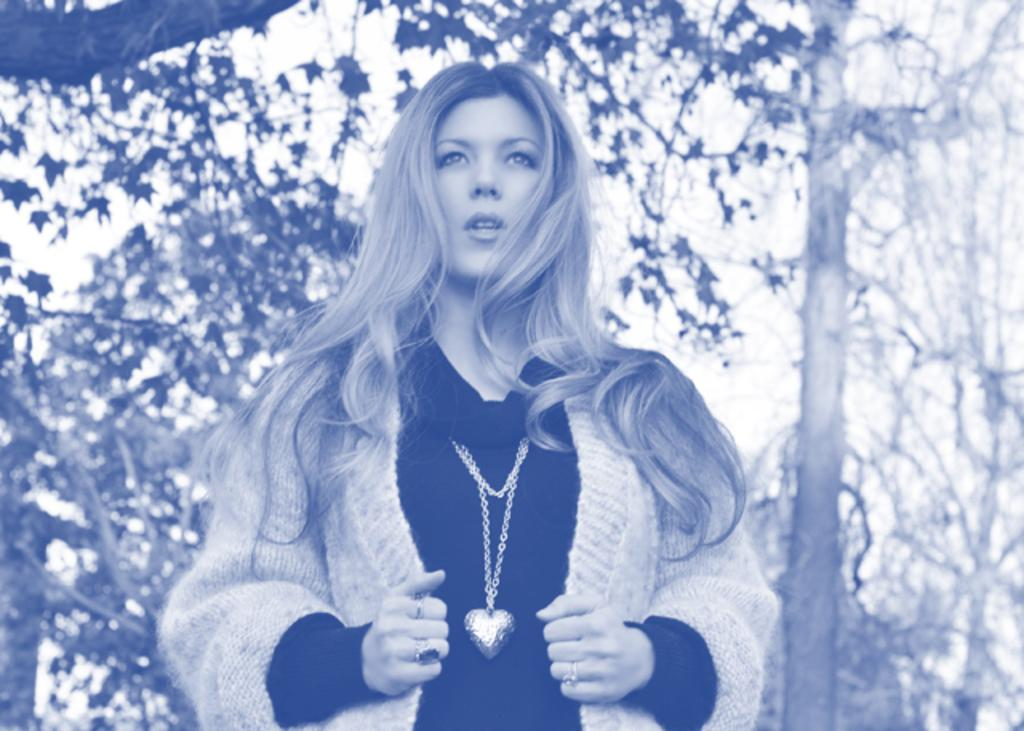Who is the main subject in the image? There is a lady in the image. What is the lady wearing in the image? The lady is wearing a coat and a chain. What can be seen in the background of the image? There are trees in the background of the image. Can you tell me how many basketballs are visible in the image? There are no basketballs present in the image. What type of hair does the lady have in the image? The provided facts do not mention the lady's hair, so we cannot determine her hair type from the image. 